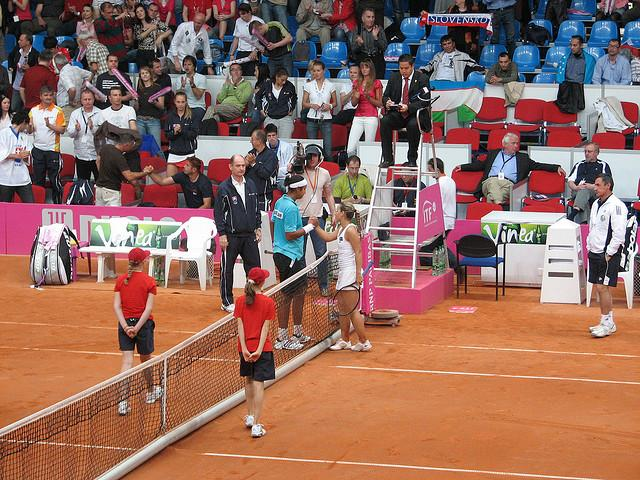At which point in the match are these players?

Choices:
A) mid way
B) beginning
C) half time
D) end end 